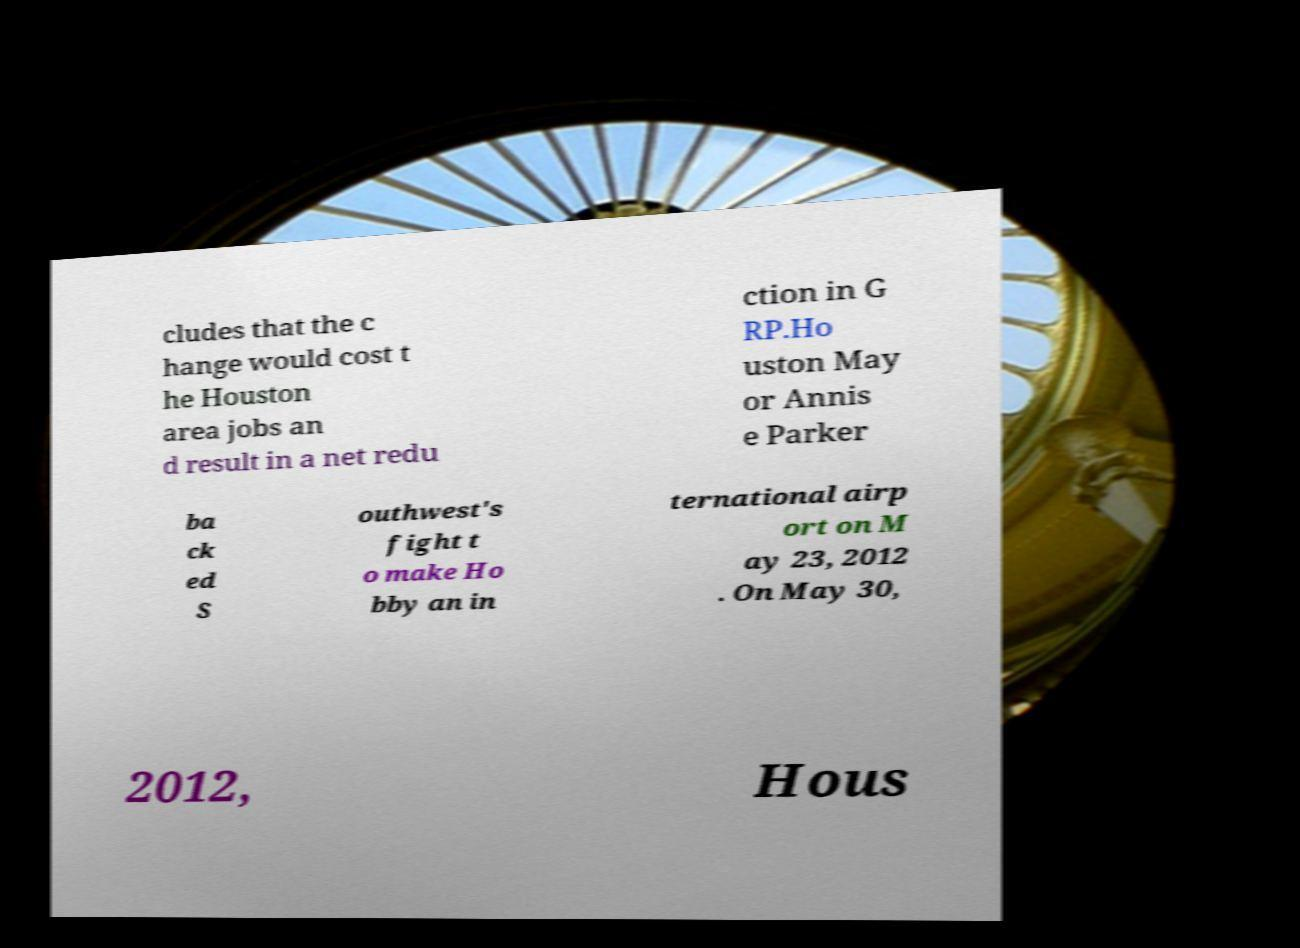There's text embedded in this image that I need extracted. Can you transcribe it verbatim? cludes that the c hange would cost t he Houston area jobs an d result in a net redu ction in G RP.Ho uston May or Annis e Parker ba ck ed S outhwest's fight t o make Ho bby an in ternational airp ort on M ay 23, 2012 . On May 30, 2012, Hous 